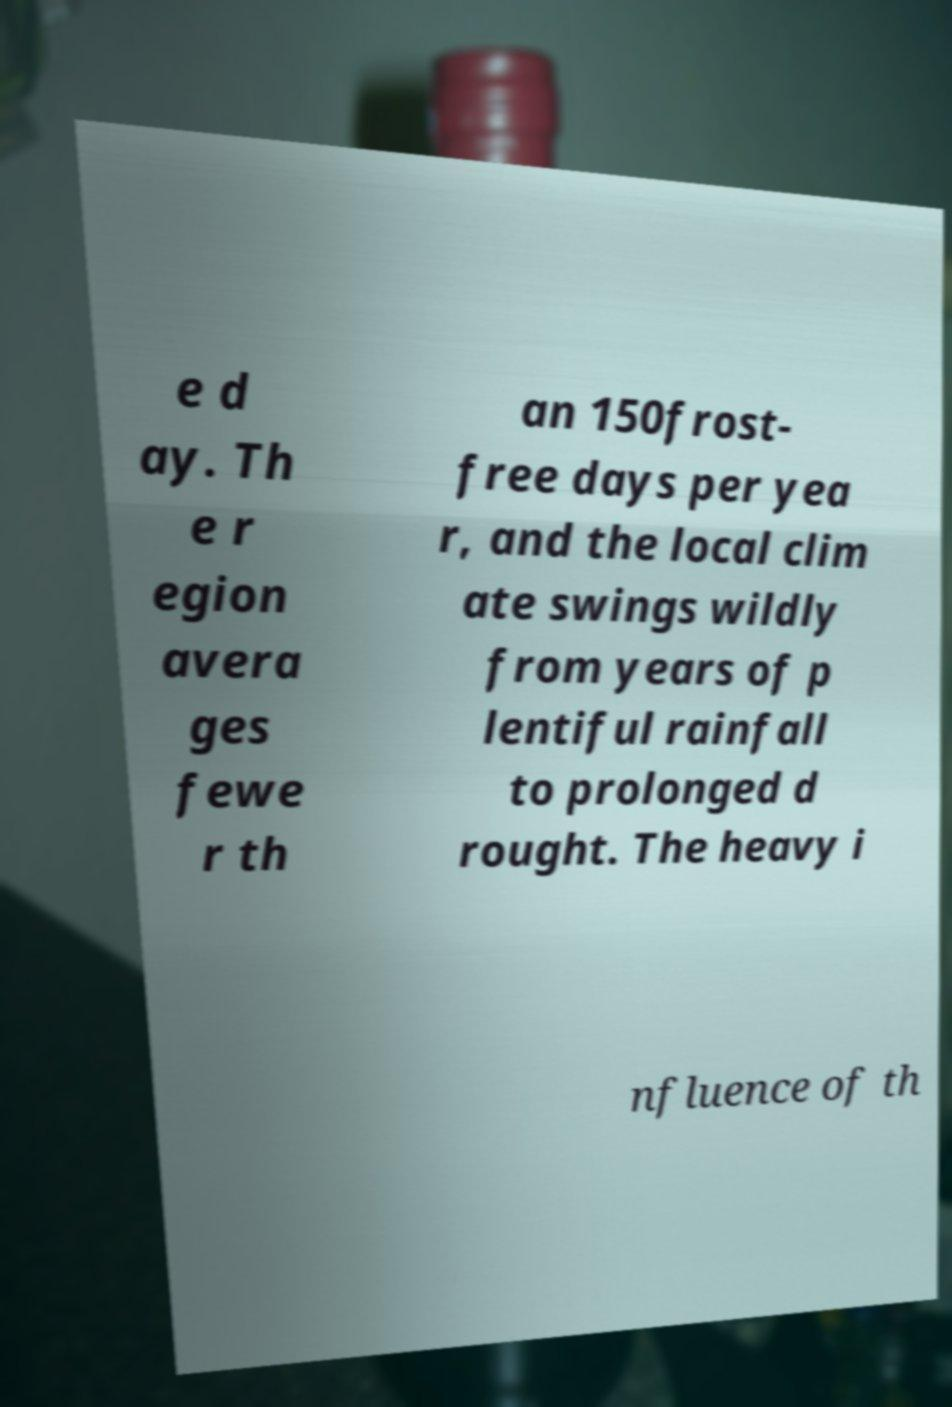Can you read and provide the text displayed in the image?This photo seems to have some interesting text. Can you extract and type it out for me? e d ay. Th e r egion avera ges fewe r th an 150frost- free days per yea r, and the local clim ate swings wildly from years of p lentiful rainfall to prolonged d rought. The heavy i nfluence of th 